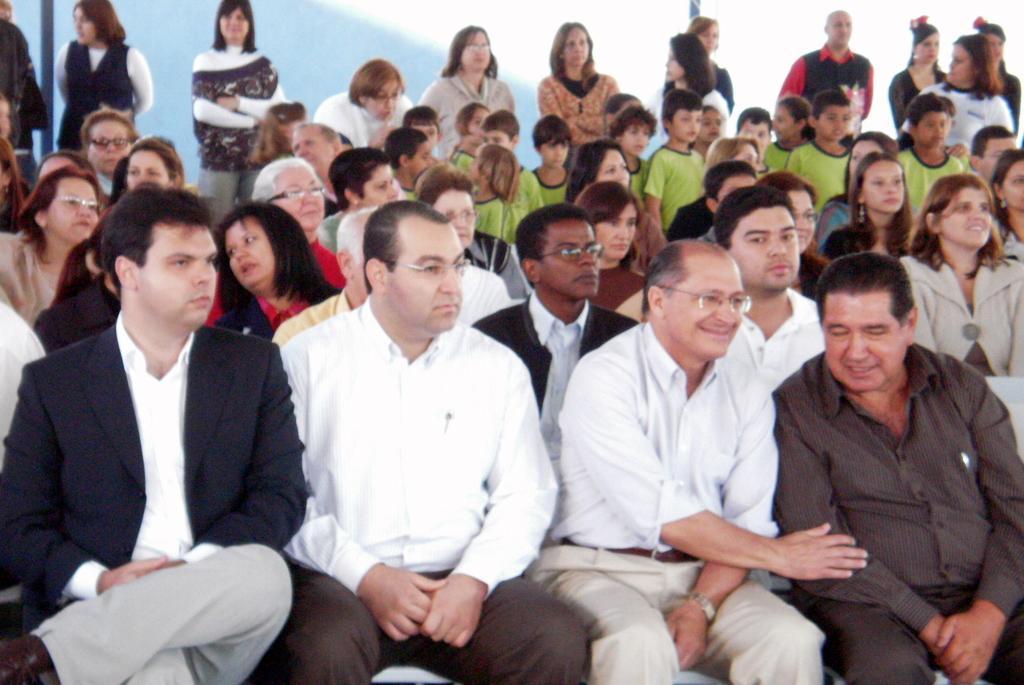Could you give a brief overview of what you see in this image? In this there is a group of persons are sitting in middle of this image and there are some persons standing in the background and there is a wall on the top of this image. 